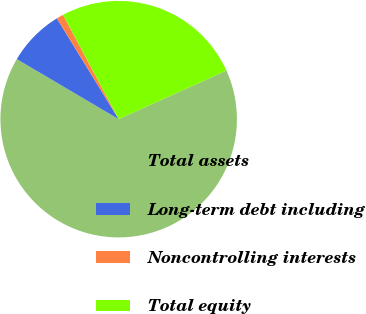Convert chart. <chart><loc_0><loc_0><loc_500><loc_500><pie_chart><fcel>Total assets<fcel>Long-term debt including<fcel>Noncontrolling interests<fcel>Total equity<nl><fcel>65.23%<fcel>7.77%<fcel>0.95%<fcel>26.06%<nl></chart> 